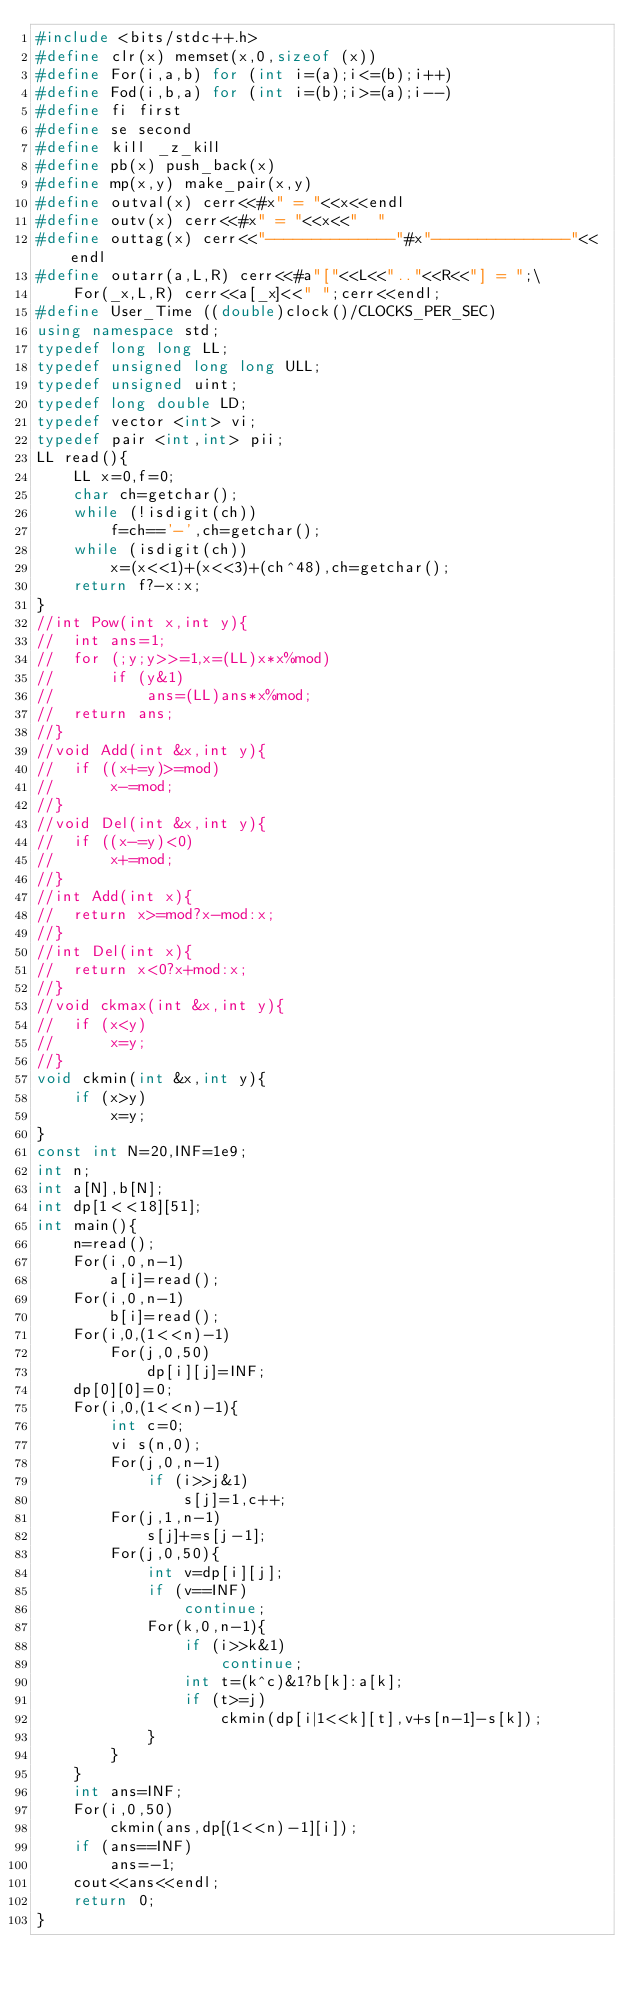Convert code to text. <code><loc_0><loc_0><loc_500><loc_500><_C++_>#include <bits/stdc++.h>
#define clr(x) memset(x,0,sizeof (x))
#define For(i,a,b) for (int i=(a);i<=(b);i++)
#define Fod(i,b,a) for (int i=(b);i>=(a);i--)
#define fi first
#define se second
#define kill _z_kill
#define pb(x) push_back(x)
#define mp(x,y) make_pair(x,y)
#define outval(x) cerr<<#x" = "<<x<<endl
#define outv(x) cerr<<#x" = "<<x<<"  "
#define outtag(x) cerr<<"--------------"#x"---------------"<<endl
#define outarr(a,L,R) cerr<<#a"["<<L<<".."<<R<<"] = ";\
	For(_x,L,R) cerr<<a[_x]<<" ";cerr<<endl;
#define User_Time ((double)clock()/CLOCKS_PER_SEC)
using namespace std;
typedef long long LL;
typedef unsigned long long ULL;
typedef unsigned uint;
typedef long double LD;
typedef vector <int> vi;
typedef pair <int,int> pii;
LL read(){
	LL x=0,f=0;
	char ch=getchar();
	while (!isdigit(ch))
		f=ch=='-',ch=getchar();
	while (isdigit(ch))
		x=(x<<1)+(x<<3)+(ch^48),ch=getchar();
	return f?-x:x;
}
//int Pow(int x,int y){
//	int ans=1;
//	for (;y;y>>=1,x=(LL)x*x%mod)
//		if (y&1)
//			ans=(LL)ans*x%mod;
//	return ans;
//}
//void Add(int &x,int y){
//	if ((x+=y)>=mod)
//		x-=mod;
//}
//void Del(int &x,int y){
//	if ((x-=y)<0)
//		x+=mod;
//}
//int Add(int x){
//	return x>=mod?x-mod:x;
//}
//int Del(int x){
//	return x<0?x+mod:x;
//}
//void ckmax(int &x,int y){
//	if (x<y)
//		x=y;
//}
void ckmin(int &x,int y){
	if (x>y)
		x=y;
}
const int N=20,INF=1e9;
int n;
int a[N],b[N];
int dp[1<<18][51];
int main(){
	n=read();
	For(i,0,n-1)
		a[i]=read();
	For(i,0,n-1)
		b[i]=read();
	For(i,0,(1<<n)-1)
		For(j,0,50)
			dp[i][j]=INF;
	dp[0][0]=0;
	For(i,0,(1<<n)-1){
		int c=0;
		vi s(n,0);
		For(j,0,n-1)
			if (i>>j&1)
				s[j]=1,c++;
		For(j,1,n-1)
			s[j]+=s[j-1];
		For(j,0,50){
			int v=dp[i][j];
			if (v==INF)
				continue;
			For(k,0,n-1){
				if (i>>k&1)
					continue;
				int t=(k^c)&1?b[k]:a[k];
				if (t>=j)
					ckmin(dp[i|1<<k][t],v+s[n-1]-s[k]);
			}
		}
	}
	int ans=INF;
	For(i,0,50)
		ckmin(ans,dp[(1<<n)-1][i]);
	if (ans==INF)
		ans=-1;
	cout<<ans<<endl;
	return 0;
}</code> 